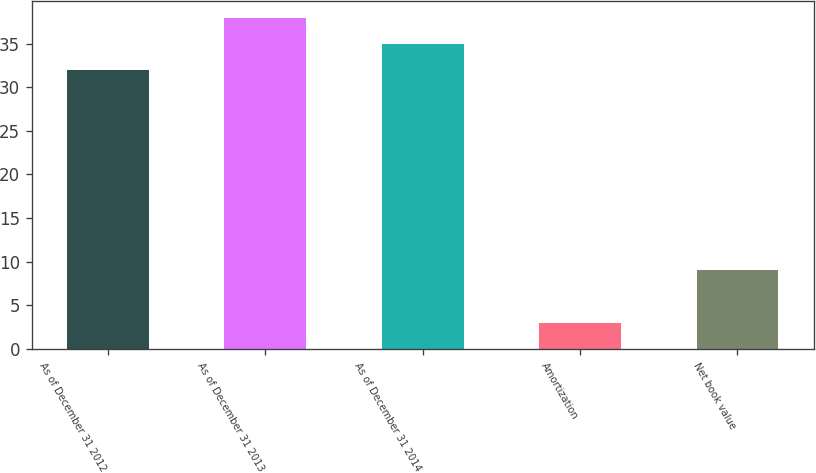Convert chart to OTSL. <chart><loc_0><loc_0><loc_500><loc_500><bar_chart><fcel>As of December 31 2012<fcel>As of December 31 2013<fcel>As of December 31 2014<fcel>Amortization<fcel>Net book value<nl><fcel>32<fcel>38<fcel>35<fcel>3<fcel>9<nl></chart> 